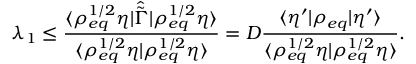<formula> <loc_0><loc_0><loc_500><loc_500>\lambda _ { 1 } \leq \frac { \langle \rho _ { e q } ^ { 1 / 2 } \eta | \hat { \tilde { \Gamma } } | \rho _ { e q } ^ { 1 / 2 } \eta \rangle } { \langle \rho _ { e q } ^ { 1 / 2 } \eta | \rho _ { e q } ^ { 1 / 2 } \eta \rangle } = D \frac { \langle \eta ^ { \prime } | \rho _ { e q } | \eta ^ { \prime } \rangle } { \langle \rho _ { e q } ^ { 1 / 2 } \eta | \rho _ { e q } ^ { 1 / 2 } \eta \rangle } .</formula> 